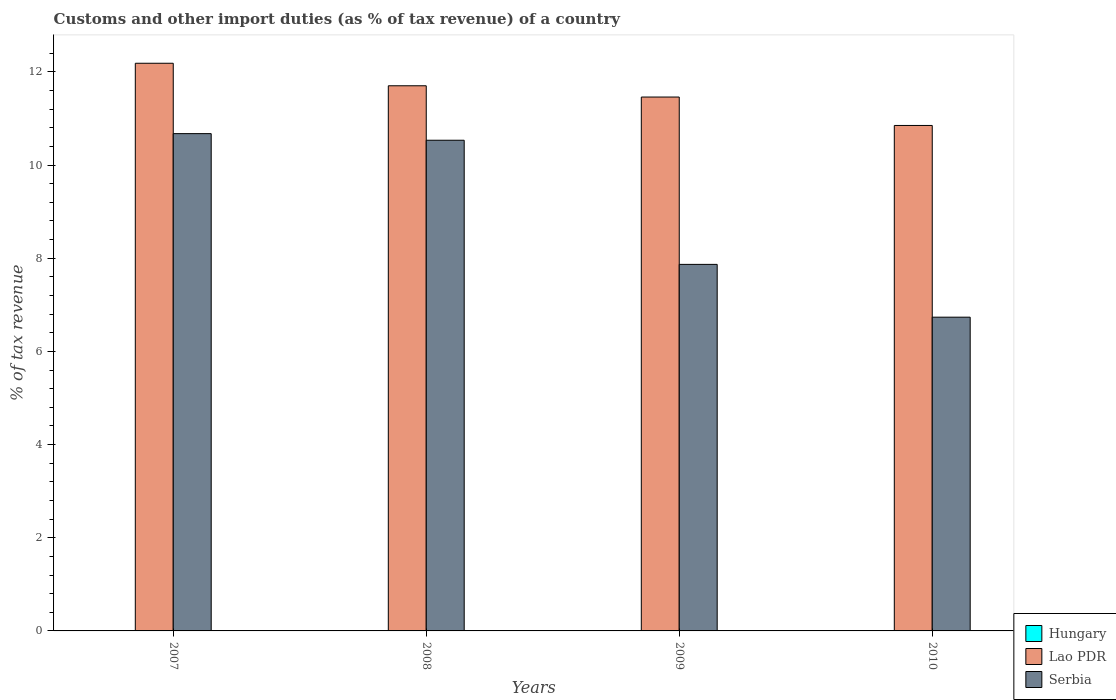How many different coloured bars are there?
Provide a succinct answer. 2. Are the number of bars on each tick of the X-axis equal?
Provide a succinct answer. Yes. How many bars are there on the 2nd tick from the left?
Ensure brevity in your answer.  2. What is the label of the 4th group of bars from the left?
Ensure brevity in your answer.  2010. What is the percentage of tax revenue from customs in Lao PDR in 2007?
Give a very brief answer. 12.19. Across all years, what is the maximum percentage of tax revenue from customs in Lao PDR?
Offer a terse response. 12.19. Across all years, what is the minimum percentage of tax revenue from customs in Serbia?
Provide a succinct answer. 6.73. What is the difference between the percentage of tax revenue from customs in Serbia in 2007 and that in 2009?
Provide a short and direct response. 2.81. What is the difference between the percentage of tax revenue from customs in Serbia in 2007 and the percentage of tax revenue from customs in Lao PDR in 2009?
Provide a succinct answer. -0.79. What is the average percentage of tax revenue from customs in Hungary per year?
Keep it short and to the point. 0. In the year 2008, what is the difference between the percentage of tax revenue from customs in Serbia and percentage of tax revenue from customs in Lao PDR?
Offer a very short reply. -1.17. What is the ratio of the percentage of tax revenue from customs in Serbia in 2009 to that in 2010?
Ensure brevity in your answer.  1.17. What is the difference between the highest and the second highest percentage of tax revenue from customs in Serbia?
Make the answer very short. 0.14. What is the difference between the highest and the lowest percentage of tax revenue from customs in Serbia?
Give a very brief answer. 3.94. Is it the case that in every year, the sum of the percentage of tax revenue from customs in Lao PDR and percentage of tax revenue from customs in Hungary is greater than the percentage of tax revenue from customs in Serbia?
Your answer should be very brief. Yes. Does the graph contain any zero values?
Provide a short and direct response. Yes. What is the title of the graph?
Give a very brief answer. Customs and other import duties (as % of tax revenue) of a country. What is the label or title of the X-axis?
Your answer should be compact. Years. What is the label or title of the Y-axis?
Make the answer very short. % of tax revenue. What is the % of tax revenue in Hungary in 2007?
Give a very brief answer. 0. What is the % of tax revenue of Lao PDR in 2007?
Keep it short and to the point. 12.19. What is the % of tax revenue in Serbia in 2007?
Offer a terse response. 10.67. What is the % of tax revenue of Lao PDR in 2008?
Offer a terse response. 11.7. What is the % of tax revenue of Serbia in 2008?
Your answer should be compact. 10.53. What is the % of tax revenue in Lao PDR in 2009?
Your answer should be very brief. 11.46. What is the % of tax revenue in Serbia in 2009?
Offer a terse response. 7.87. What is the % of tax revenue in Hungary in 2010?
Offer a terse response. 0. What is the % of tax revenue in Lao PDR in 2010?
Provide a short and direct response. 10.85. What is the % of tax revenue of Serbia in 2010?
Provide a short and direct response. 6.73. Across all years, what is the maximum % of tax revenue in Lao PDR?
Your answer should be compact. 12.19. Across all years, what is the maximum % of tax revenue of Serbia?
Provide a succinct answer. 10.67. Across all years, what is the minimum % of tax revenue in Lao PDR?
Make the answer very short. 10.85. Across all years, what is the minimum % of tax revenue in Serbia?
Your answer should be very brief. 6.73. What is the total % of tax revenue in Lao PDR in the graph?
Provide a short and direct response. 46.2. What is the total % of tax revenue in Serbia in the graph?
Ensure brevity in your answer.  35.81. What is the difference between the % of tax revenue of Lao PDR in 2007 and that in 2008?
Give a very brief answer. 0.48. What is the difference between the % of tax revenue of Serbia in 2007 and that in 2008?
Offer a terse response. 0.14. What is the difference between the % of tax revenue of Lao PDR in 2007 and that in 2009?
Give a very brief answer. 0.72. What is the difference between the % of tax revenue of Serbia in 2007 and that in 2009?
Your answer should be very brief. 2.81. What is the difference between the % of tax revenue in Lao PDR in 2007 and that in 2010?
Your answer should be very brief. 1.34. What is the difference between the % of tax revenue in Serbia in 2007 and that in 2010?
Offer a terse response. 3.94. What is the difference between the % of tax revenue in Lao PDR in 2008 and that in 2009?
Your answer should be compact. 0.24. What is the difference between the % of tax revenue in Serbia in 2008 and that in 2009?
Ensure brevity in your answer.  2.66. What is the difference between the % of tax revenue of Lao PDR in 2008 and that in 2010?
Your answer should be very brief. 0.85. What is the difference between the % of tax revenue of Serbia in 2008 and that in 2010?
Provide a succinct answer. 3.8. What is the difference between the % of tax revenue in Lao PDR in 2009 and that in 2010?
Offer a terse response. 0.61. What is the difference between the % of tax revenue of Serbia in 2009 and that in 2010?
Ensure brevity in your answer.  1.13. What is the difference between the % of tax revenue in Lao PDR in 2007 and the % of tax revenue in Serbia in 2008?
Offer a very short reply. 1.65. What is the difference between the % of tax revenue in Lao PDR in 2007 and the % of tax revenue in Serbia in 2009?
Offer a very short reply. 4.32. What is the difference between the % of tax revenue of Lao PDR in 2007 and the % of tax revenue of Serbia in 2010?
Make the answer very short. 5.45. What is the difference between the % of tax revenue in Lao PDR in 2008 and the % of tax revenue in Serbia in 2009?
Offer a very short reply. 3.83. What is the difference between the % of tax revenue in Lao PDR in 2008 and the % of tax revenue in Serbia in 2010?
Offer a terse response. 4.97. What is the difference between the % of tax revenue of Lao PDR in 2009 and the % of tax revenue of Serbia in 2010?
Your answer should be compact. 4.73. What is the average % of tax revenue in Lao PDR per year?
Give a very brief answer. 11.55. What is the average % of tax revenue of Serbia per year?
Keep it short and to the point. 8.95. In the year 2007, what is the difference between the % of tax revenue in Lao PDR and % of tax revenue in Serbia?
Your response must be concise. 1.51. In the year 2008, what is the difference between the % of tax revenue of Lao PDR and % of tax revenue of Serbia?
Give a very brief answer. 1.17. In the year 2009, what is the difference between the % of tax revenue in Lao PDR and % of tax revenue in Serbia?
Ensure brevity in your answer.  3.59. In the year 2010, what is the difference between the % of tax revenue of Lao PDR and % of tax revenue of Serbia?
Make the answer very short. 4.12. What is the ratio of the % of tax revenue of Lao PDR in 2007 to that in 2008?
Your answer should be very brief. 1.04. What is the ratio of the % of tax revenue in Serbia in 2007 to that in 2008?
Give a very brief answer. 1.01. What is the ratio of the % of tax revenue of Lao PDR in 2007 to that in 2009?
Offer a terse response. 1.06. What is the ratio of the % of tax revenue in Serbia in 2007 to that in 2009?
Your answer should be compact. 1.36. What is the ratio of the % of tax revenue of Lao PDR in 2007 to that in 2010?
Provide a succinct answer. 1.12. What is the ratio of the % of tax revenue of Serbia in 2007 to that in 2010?
Make the answer very short. 1.58. What is the ratio of the % of tax revenue of Lao PDR in 2008 to that in 2009?
Provide a succinct answer. 1.02. What is the ratio of the % of tax revenue of Serbia in 2008 to that in 2009?
Offer a terse response. 1.34. What is the ratio of the % of tax revenue of Lao PDR in 2008 to that in 2010?
Give a very brief answer. 1.08. What is the ratio of the % of tax revenue of Serbia in 2008 to that in 2010?
Your answer should be compact. 1.56. What is the ratio of the % of tax revenue in Lao PDR in 2009 to that in 2010?
Ensure brevity in your answer.  1.06. What is the ratio of the % of tax revenue of Serbia in 2009 to that in 2010?
Give a very brief answer. 1.17. What is the difference between the highest and the second highest % of tax revenue in Lao PDR?
Your answer should be very brief. 0.48. What is the difference between the highest and the second highest % of tax revenue in Serbia?
Ensure brevity in your answer.  0.14. What is the difference between the highest and the lowest % of tax revenue of Lao PDR?
Offer a very short reply. 1.34. What is the difference between the highest and the lowest % of tax revenue of Serbia?
Make the answer very short. 3.94. 